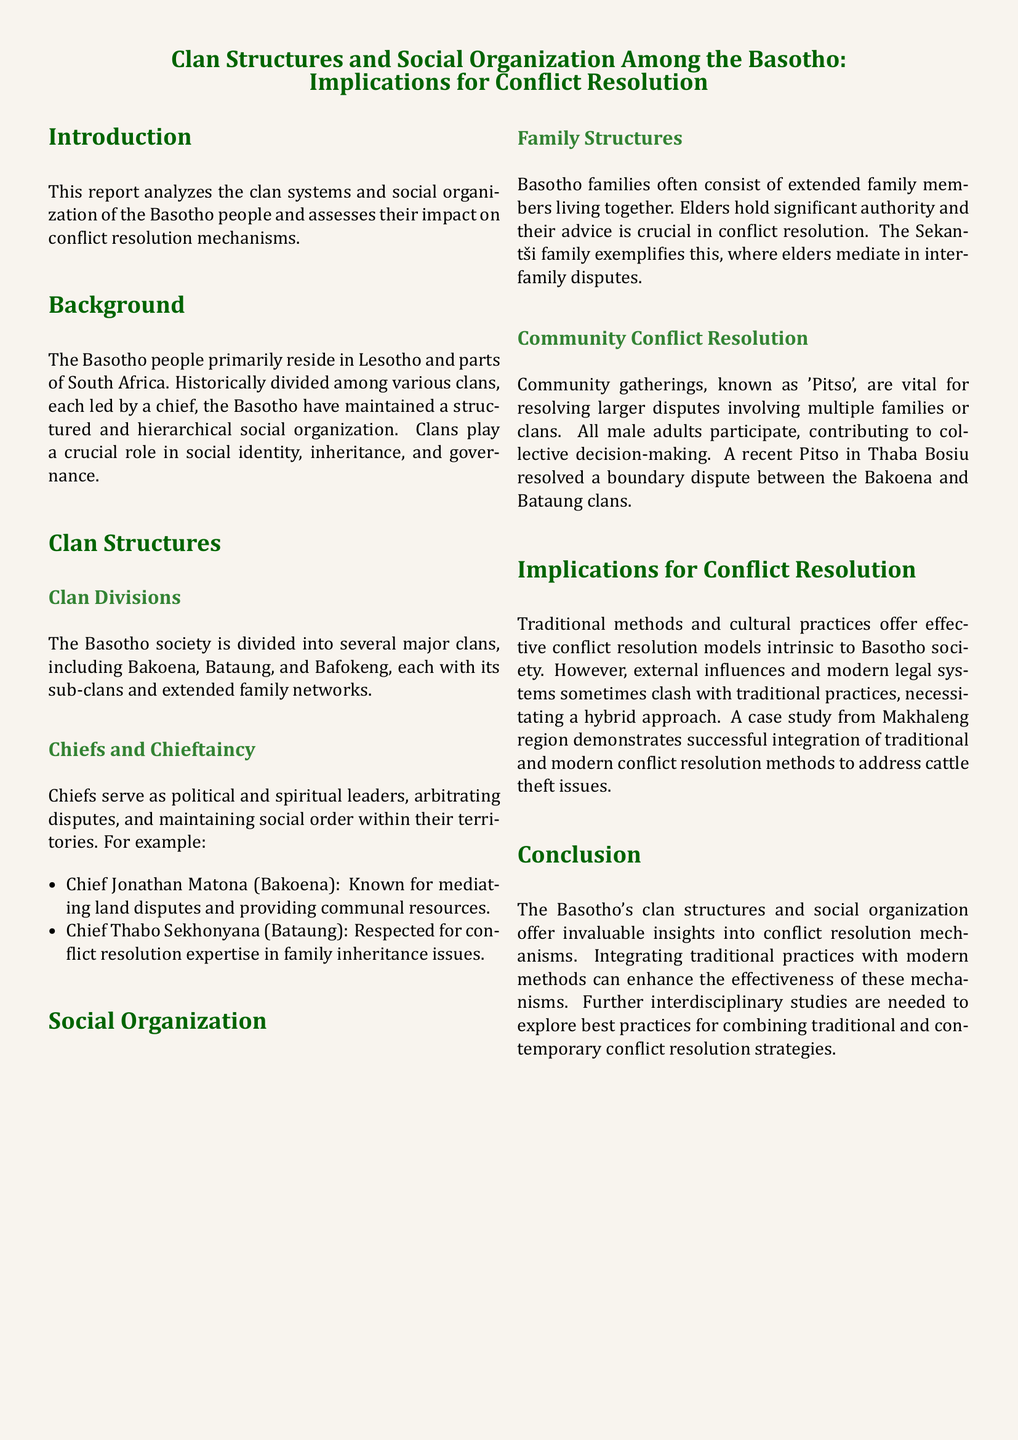What are the major clans of the Basotho? The document lists major clans including Bakoena, Bataung, and Bafokeng, which represent significant clan divisions.
Answer: Bakoena, Bataung, Bafokeng Who is the chief known for mediating land disputes? The document specifies Chief Jonathan Matona of the Bakoena clan as known for mediating land disputes and providing communal resources.
Answer: Chief Jonathan Matona What is the role of elders in Basotho family structures? Elders hold significant authority in family structures and their advice is crucial in conflict resolution, as stated in the document.
Answer: Authority What is a Pitso? The document describes a Pitso as a community gathering vital for resolving larger disputes involving multiple families or clans.
Answer: Community gathering What case study does the report mention related to conflict resolution? The document refers to a case study from the Makhaleng region illustrating the integration of traditional and modern conflict resolution methods for cattle theft issues.
Answer: Makhaleng region Which chief is respected for conflict resolution expertise in family inheritance issues? The document identifies Chief Thabo Sekhonyana of the Bataung clan as respected for his conflict resolution expertise in family inheritance issues.
Answer: Chief Thabo Sekhonyana What type of report is this document categorized as? The document is categorized as a lab report analyzing clan systems and social organization of the Basotho people.
Answer: Lab report What integration approach does the conclusion suggest? The conclusion emphasizes the importance of integrating traditional practices with modern methods to enhance conflict resolution mechanisms.
Answer: Integrating traditional practices with modern methods 